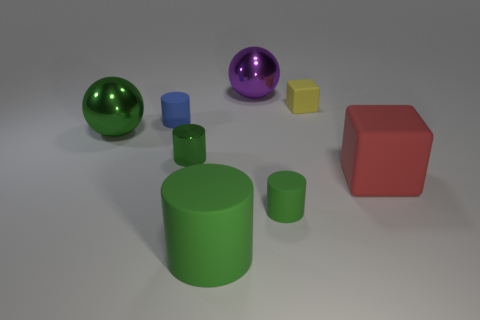Subtract all cyan cubes. How many green cylinders are left? 3 Subtract all red cylinders. Subtract all yellow balls. How many cylinders are left? 4 Add 2 large purple things. How many objects exist? 10 Subtract all cubes. How many objects are left? 6 Subtract all red matte blocks. Subtract all large green spheres. How many objects are left? 6 Add 1 tiny metallic cylinders. How many tiny metallic cylinders are left? 2 Add 7 small cubes. How many small cubes exist? 8 Subtract 0 red cylinders. How many objects are left? 8 